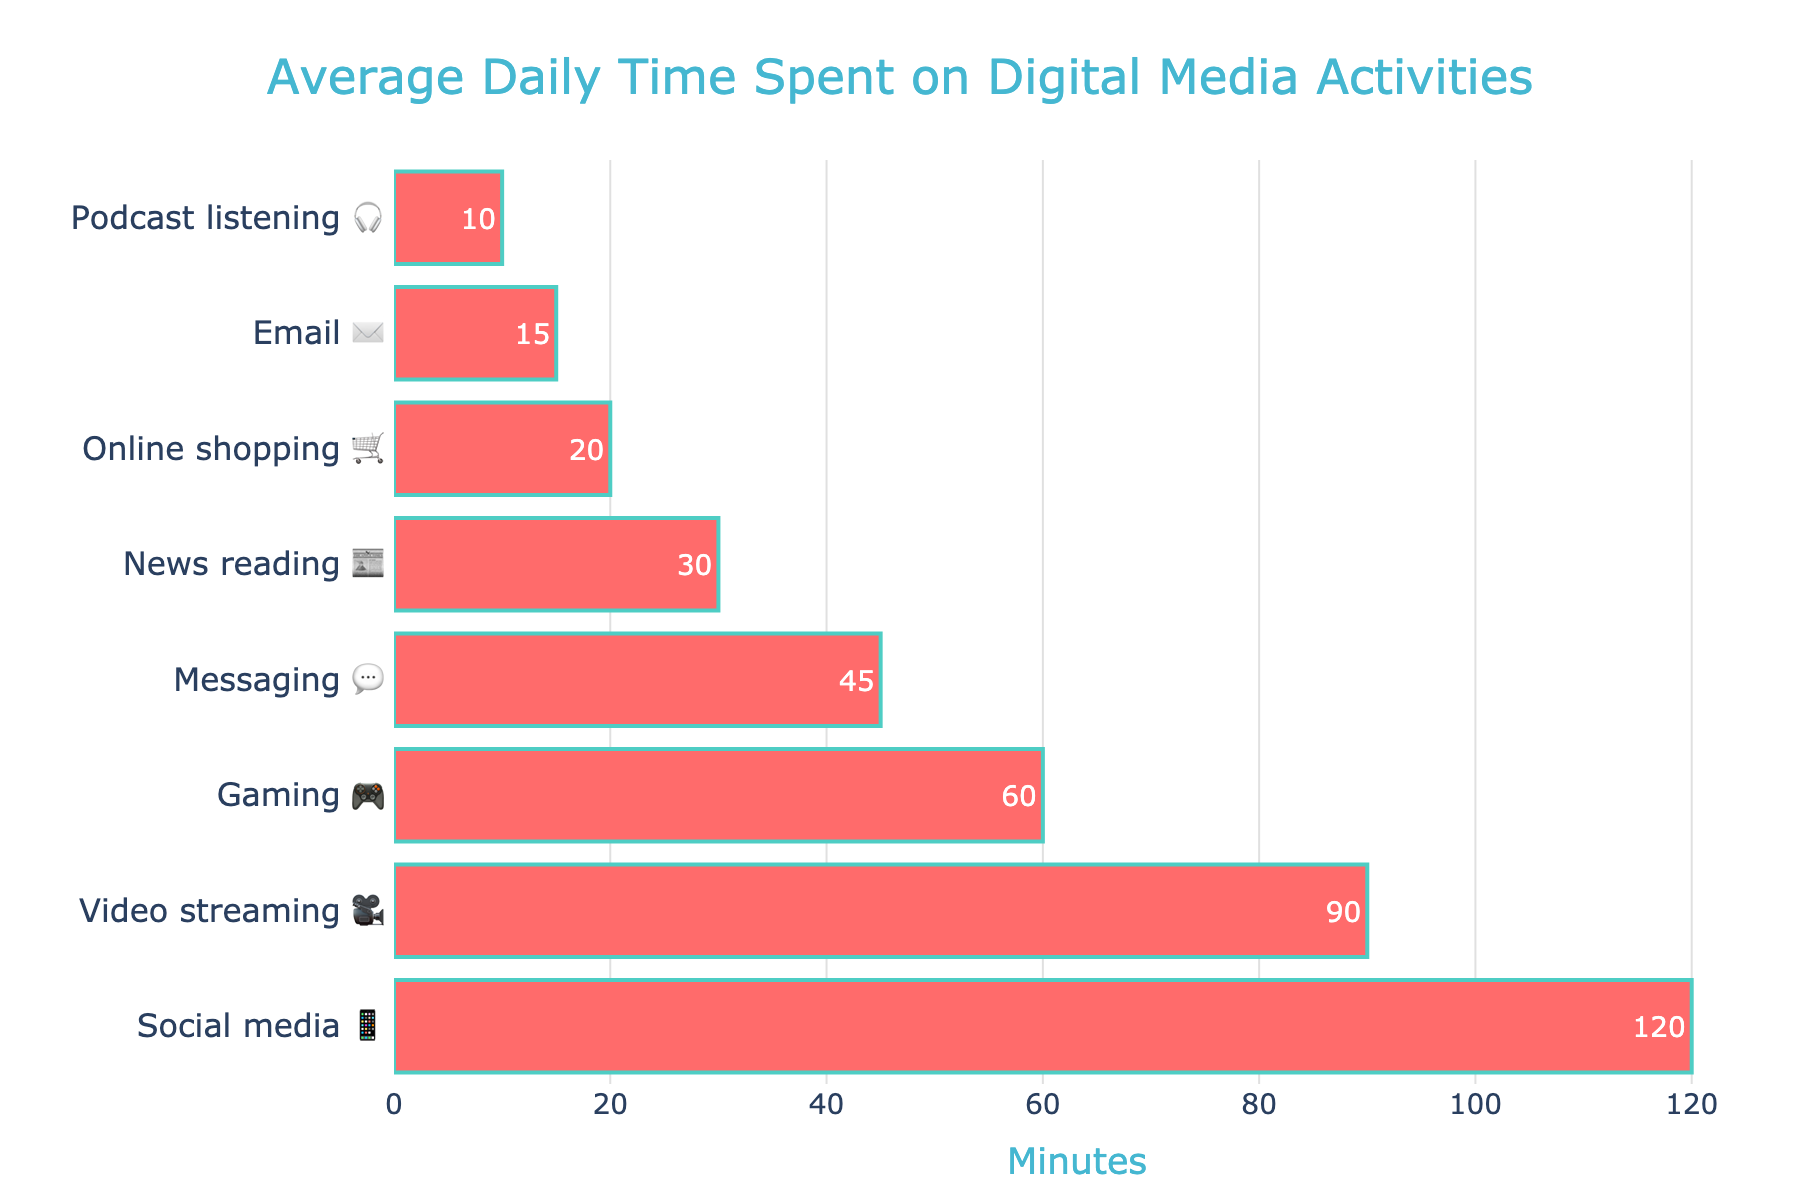What is the title of the chart? The title is located at the top center of the chart. It reads "Average Daily Time Spent on Digital Media Activities".
Answer: Average Daily Time Spent on Digital Media Activities Which activity has the highest average daily time spent? By looking at the bars, the longest bar corresponds to "Social media 📱" with an average of 120 minutes.
Answer: Social media 📱 How much time do people spend on gaming 🎮 daily? The bar for "Gaming 🎮" reaches up to 60 minutes.
Answer: 60 minutes Which activity is in the middle of the chart in terms of average daily time spent? The activities are sorted in descending order. The middle activity is "Messaging 💬" with 45 minutes.
Answer: Messaging 💬 What is the combined total of average daily time spent on social media 📱 and video streaming 🎥? Social media 📱 has 120 minutes and video streaming 🎥 has 90 minutes. Adding these together, 120 + 90.
Answer: 210 minutes How many activities have an average daily time of less than 30 minutes? Looking at the bars and their corresponding times, three activities fall under this category: Online shopping 🛒, Email ✉️, and Podcast listening 🎧.
Answer: 3 activities Which activity has the least average daily time spent? The shortest bar represents "Podcast listening 🎧" with 10 minutes.
Answer: Podcast listening 🎧 By how many minutes does the time spent on video streaming 🎥 exceed the time spent on gaming 🎮? Video streaming 🎥 has 90 minutes, and gaming 🎮 has 60 minutes. The difference is 90 - 60.
Answer: 30 minutes What is the total average daily time spent on all activities combined? Summing up all the times: 120 + 90 + 60 + 45 + 30 + 20 + 15 + 10. The total is 390 minutes.
Answer: 390 minutes Which activities have more average daily time spent than online shopping 🛒? Online shopping 🛒 has 20 minutes. All activities with more than 20 minutes are: Social media 📱, Video streaming 🎥, Gaming 🎮, Messaging 💬, and News reading 📰.
Answer: 5 activities 